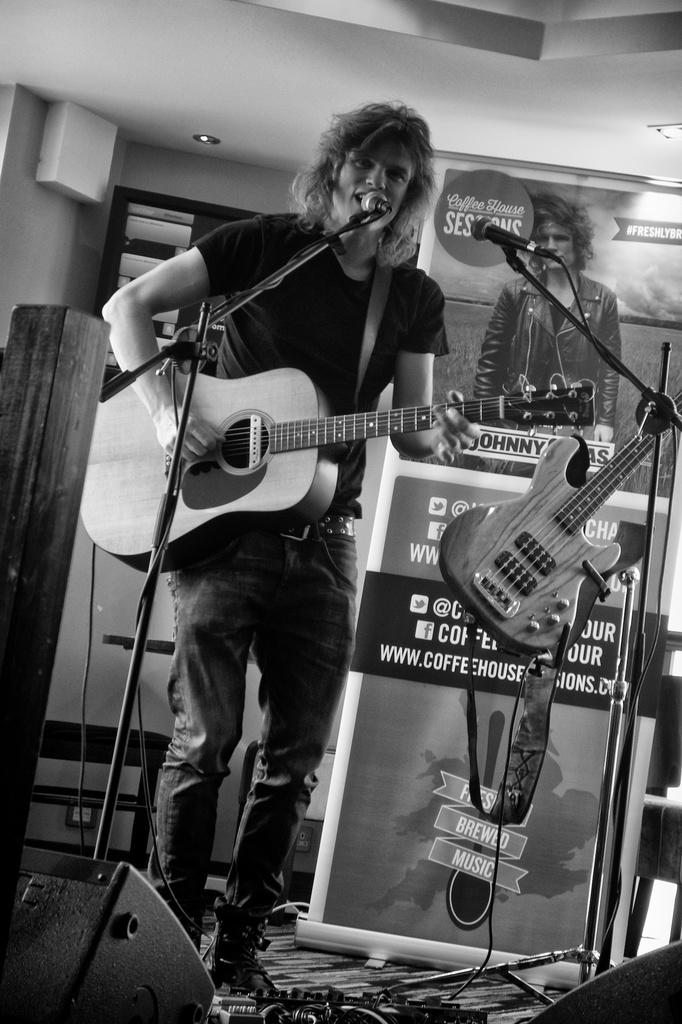What is the man in the image doing? The man is standing, playing the guitar, and singing on a microphone. What is the man holding in his hand? The man is holding a guitar in his hand. What can be seen in the background of the image? There is a poster, another guitar, a wall, and a light in the background. What type of seed is the man planting in the image? There is no seed or planting activity present in the image; the man is playing a guitar and singing on a microphone. What type of cow can be seen in the background of the image? There is no cow present in the image; the background features a poster, another guitar, a wall, and a light. 